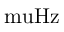<formula> <loc_0><loc_0><loc_500><loc_500>{ \ m u H z }</formula> 